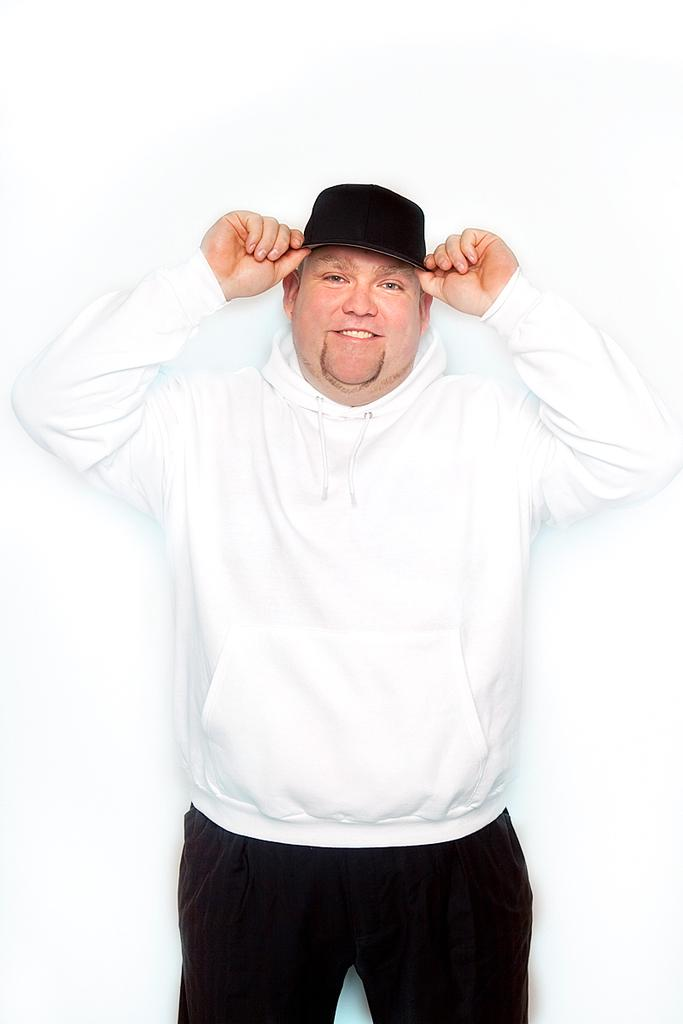Who is the main subject in the image? There is a man in the image. What is the man wearing on his upper body? The man is wearing a white hoodie. What is the man wearing on his lower body? The man is wearing black trousers. What is the man wearing on his head? The man is wearing a black hat. What is the man doing in the image? The man is posing for a photo. What color is the background of the man? The background of the man is white. What type of stone can be seen in the man's hand in the image? There is no stone present in the man's hand or in the image. What kind of seed is the man holding in the image? There is no seed present in the image. 